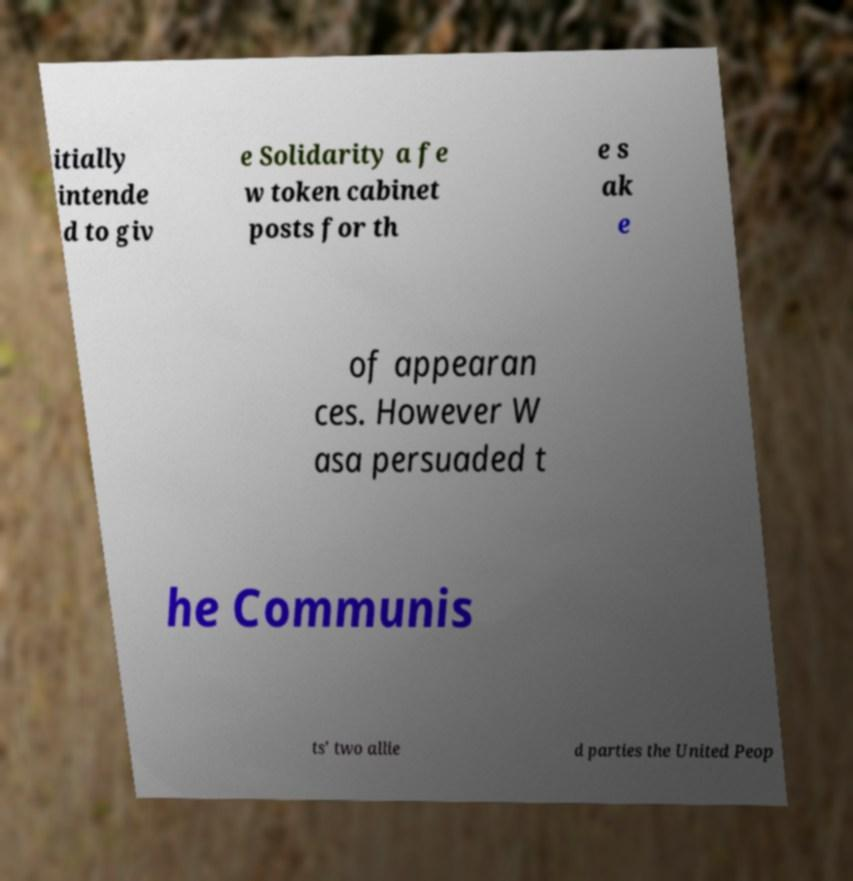There's text embedded in this image that I need extracted. Can you transcribe it verbatim? itially intende d to giv e Solidarity a fe w token cabinet posts for th e s ak e of appearan ces. However W asa persuaded t he Communis ts' two allie d parties the United Peop 